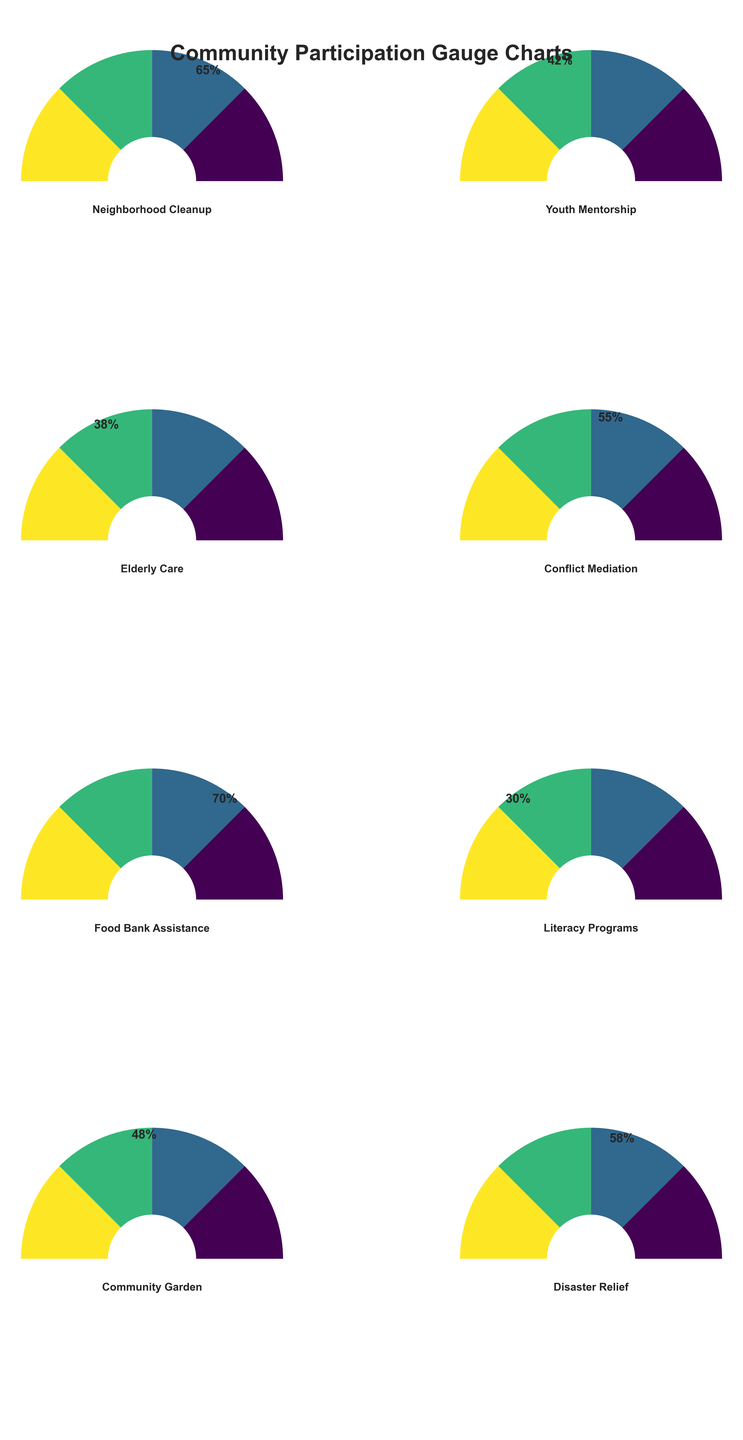What program has the highest participation percentage? The figures show gauge charts representing participation percentages. The 'Food Bank Assistance' program has the needle pointing to the highest value at 70%.
Answer: Food Bank Assistance Which program has the lowest participation percentage? Looking at the gauge charts, the 'Literacy Programs' needle is pointing at the lowest value, which is 30%.
Answer: Literacy Programs What is the average participation percentage of all programs combined? To find the average, sum all participation percentages (65 + 42 + 38 + 55 + 70 + 30 + 48 + 58) = 406. There are 8 programs, so the average is 406 / 8 = 50.75%
Answer: 50.75% How many programs have a participation percentage above 50%? By inspecting the gauges, the programs with participation percentages above 50% are 'Neighborhood Cleanup', 'Conflict Mediation', 'Food Bank Assistance', and 'Disaster Relief'. This totals to 4 programs.
Answer: 4 Which program has a higher participation percentage: 'Youth Mentorship' or 'Elderly Care'? Comparing the gauges of 'Youth Mentorship' and 'Elderly Care', the needles point to 42% and 38% respectively. Therefore, 'Youth Mentorship' has a higher participation percentage.
Answer: Youth Mentorship By how much does the 'Neighborhood Cleanup' participation exceed the 'Community Garden' participation? Inspecting the gauges, 'Neighborhood Cleanup' is at 65% and 'Community Garden' is at 48%. The difference is 65% - 48% = 17%.
Answer: 17% Which two programs have the closest participation percentages? Comparing all charts, 'Conflict Mediation' at 55% and 'Disaster Relief' at 58% are the closest with a difference of only 3%.
Answer: Conflict Mediation and Disaster Relief What is the median participation percentage among all the programs? Listing the percentages in ascending order: 30, 38, 42, 48, 55, 58, 65, 70. The median is the average of the 4th and 5th values: (48 + 55) / 2 = 51.5%.
Answer: 51.5% Are there more programs with participation above the average or below the average? The calculated average is 50.75%. Programs above are 'Neighborhood Cleanup', 'Conflict Mediation', 'Food Bank Assistance', and 'Disaster Relief'. Programs below are 'Youth Mentorship', 'Elderly Care', 'Literacy Programs', and 'Community Garden'. There are 4 programs in each category.
Answer: Equal 